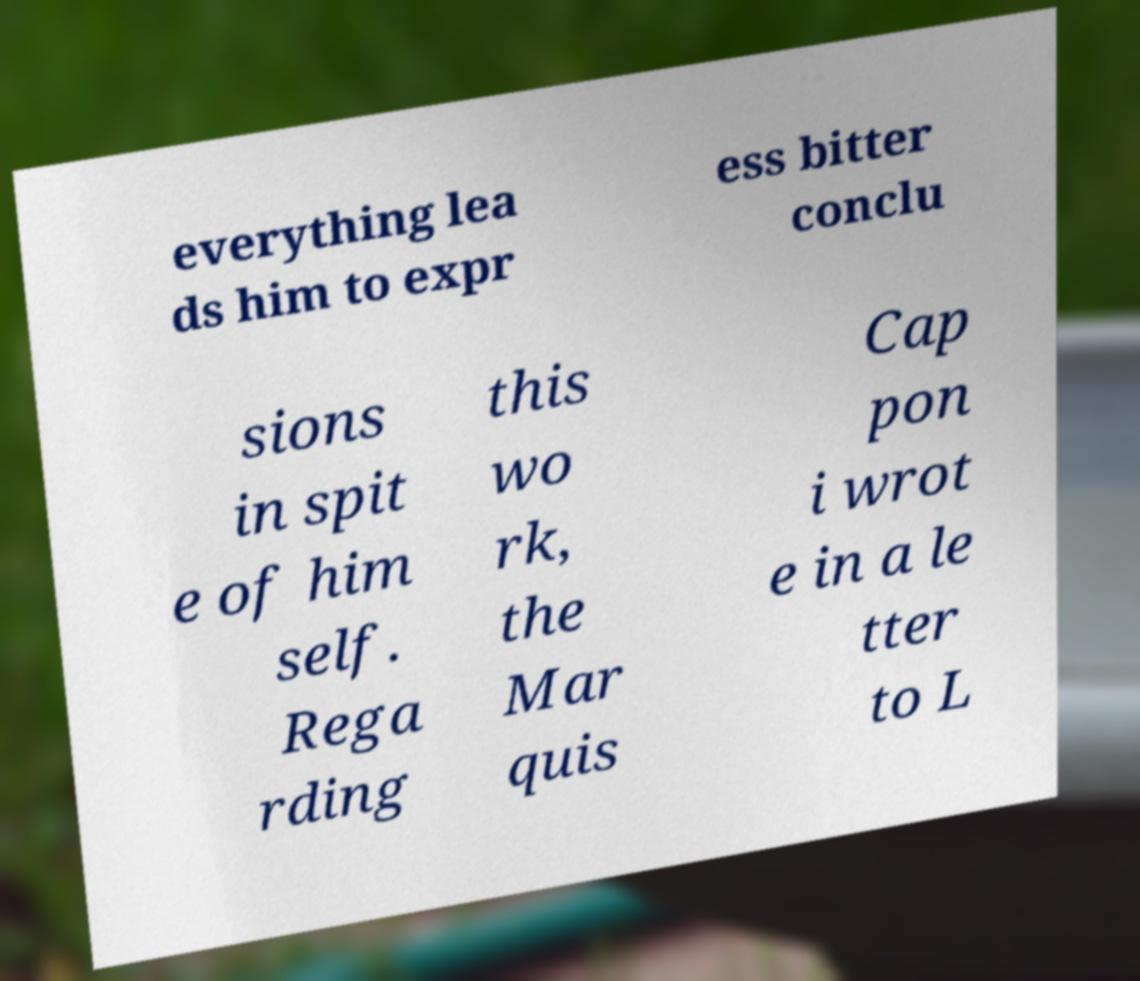I need the written content from this picture converted into text. Can you do that? everything lea ds him to expr ess bitter conclu sions in spit e of him self. Rega rding this wo rk, the Mar quis Cap pon i wrot e in a le tter to L 